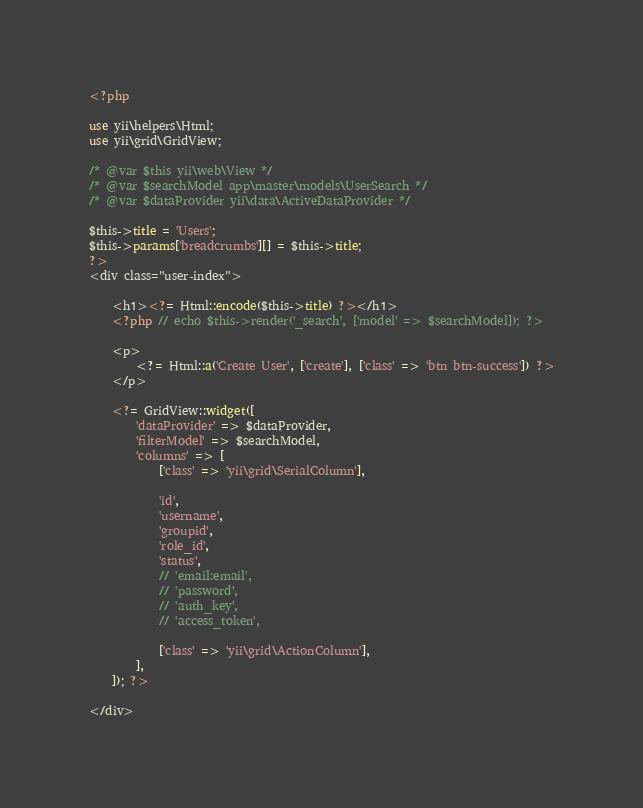<code> <loc_0><loc_0><loc_500><loc_500><_PHP_><?php

use yii\helpers\Html;
use yii\grid\GridView;

/* @var $this yii\web\View */
/* @var $searchModel app\master\models\UserSearch */
/* @var $dataProvider yii\data\ActiveDataProvider */

$this->title = 'Users';
$this->params['breadcrumbs'][] = $this->title;
?>
<div class="user-index">

    <h1><?= Html::encode($this->title) ?></h1>
    <?php // echo $this->render('_search', ['model' => $searchModel]); ?>

    <p>
        <?= Html::a('Create User', ['create'], ['class' => 'btn btn-success']) ?>
    </p>

    <?= GridView::widget([
        'dataProvider' => $dataProvider,
        'filterModel' => $searchModel,
        'columns' => [
            ['class' => 'yii\grid\SerialColumn'],

            'id',
            'username',
            'groupid',
            'role_id',
            'status',
            // 'email:email',
            // 'password',
            // 'auth_key',
            // 'access_token',

            ['class' => 'yii\grid\ActionColumn'],
        ],
    ]); ?>

</div>
</code> 